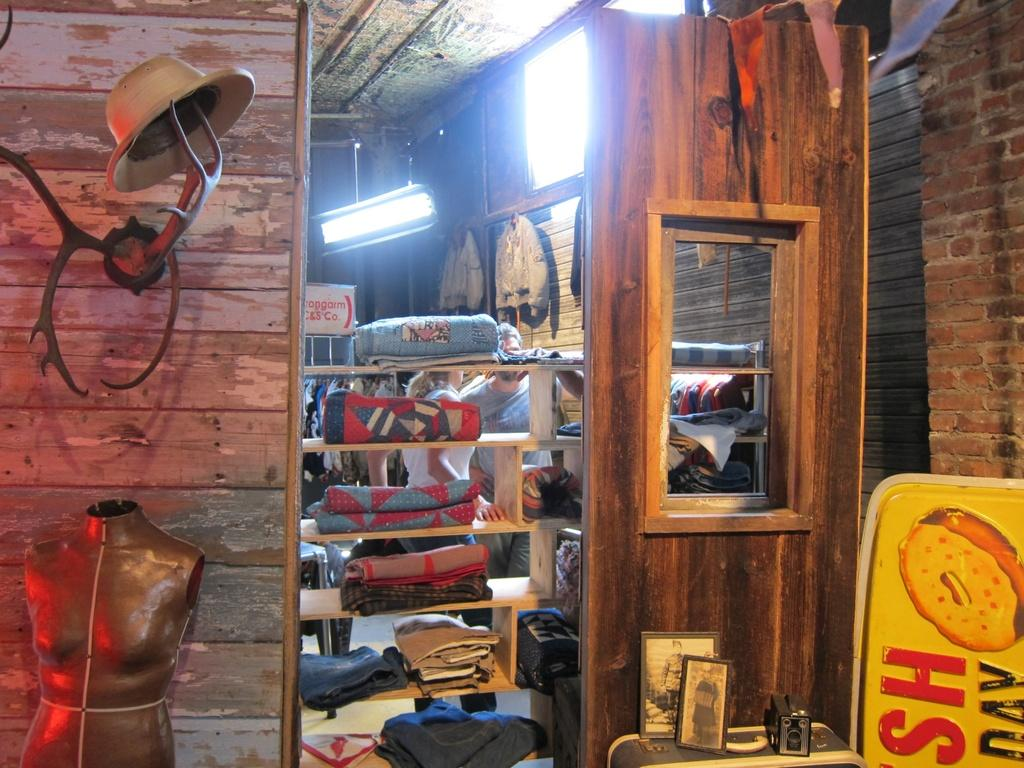What type of storage is used for the blankets in the image? The blankets are stored in wooden racks in the image. What part of the room can be seen above the wooden racks? The ceiling is visible in the image. What provides illumination in the room? A light source is present in the image. What type of decorative items are present in the image? There are photo frames in the image. What figure is present in the room? A mannequin is present in the image. What type of decoration is visible in the image? Paper flags are visible in the image. What surface is used for displaying or writing on? There is a board in the image. What type of items are stored or displayed on the wooden racks? Clothes are present in the image. What part of the room can be seen on the sides of the wooden racks? The wall is visible in the image. What additional objects can be seen in the image? There are additional objects in the image. How many yams are displayed on the board in the image? There are no yams present in the image. What type of star can be seen in the photo frames in the image? There are no stars visible in the photo frames in the image. 